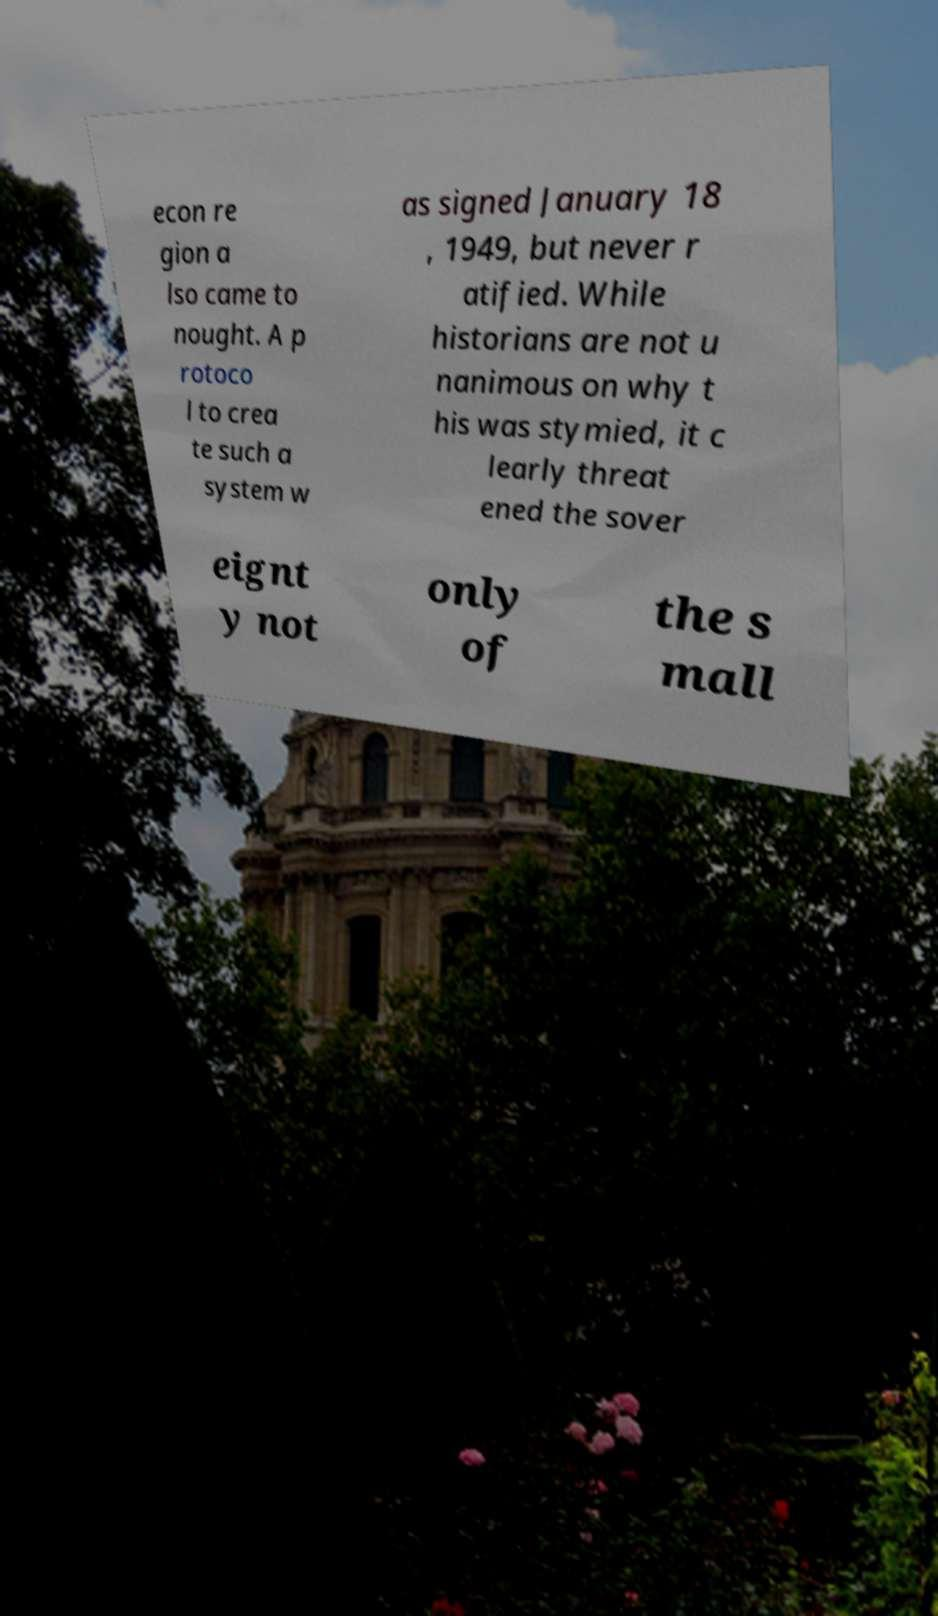Please read and relay the text visible in this image. What does it say? econ re gion a lso came to nought. A p rotoco l to crea te such a system w as signed January 18 , 1949, but never r atified. While historians are not u nanimous on why t his was stymied, it c learly threat ened the sover eignt y not only of the s mall 